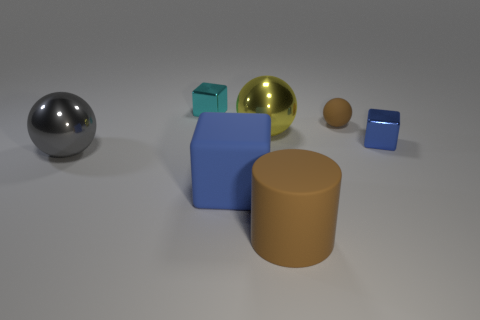Add 2 tiny gray rubber cubes. How many objects exist? 9 Subtract all cylinders. How many objects are left? 6 Add 1 gray metal balls. How many gray metal balls are left? 2 Add 4 large gray spheres. How many large gray spheres exist? 5 Subtract 0 gray cylinders. How many objects are left? 7 Subtract all gray spheres. Subtract all tiny blue cubes. How many objects are left? 5 